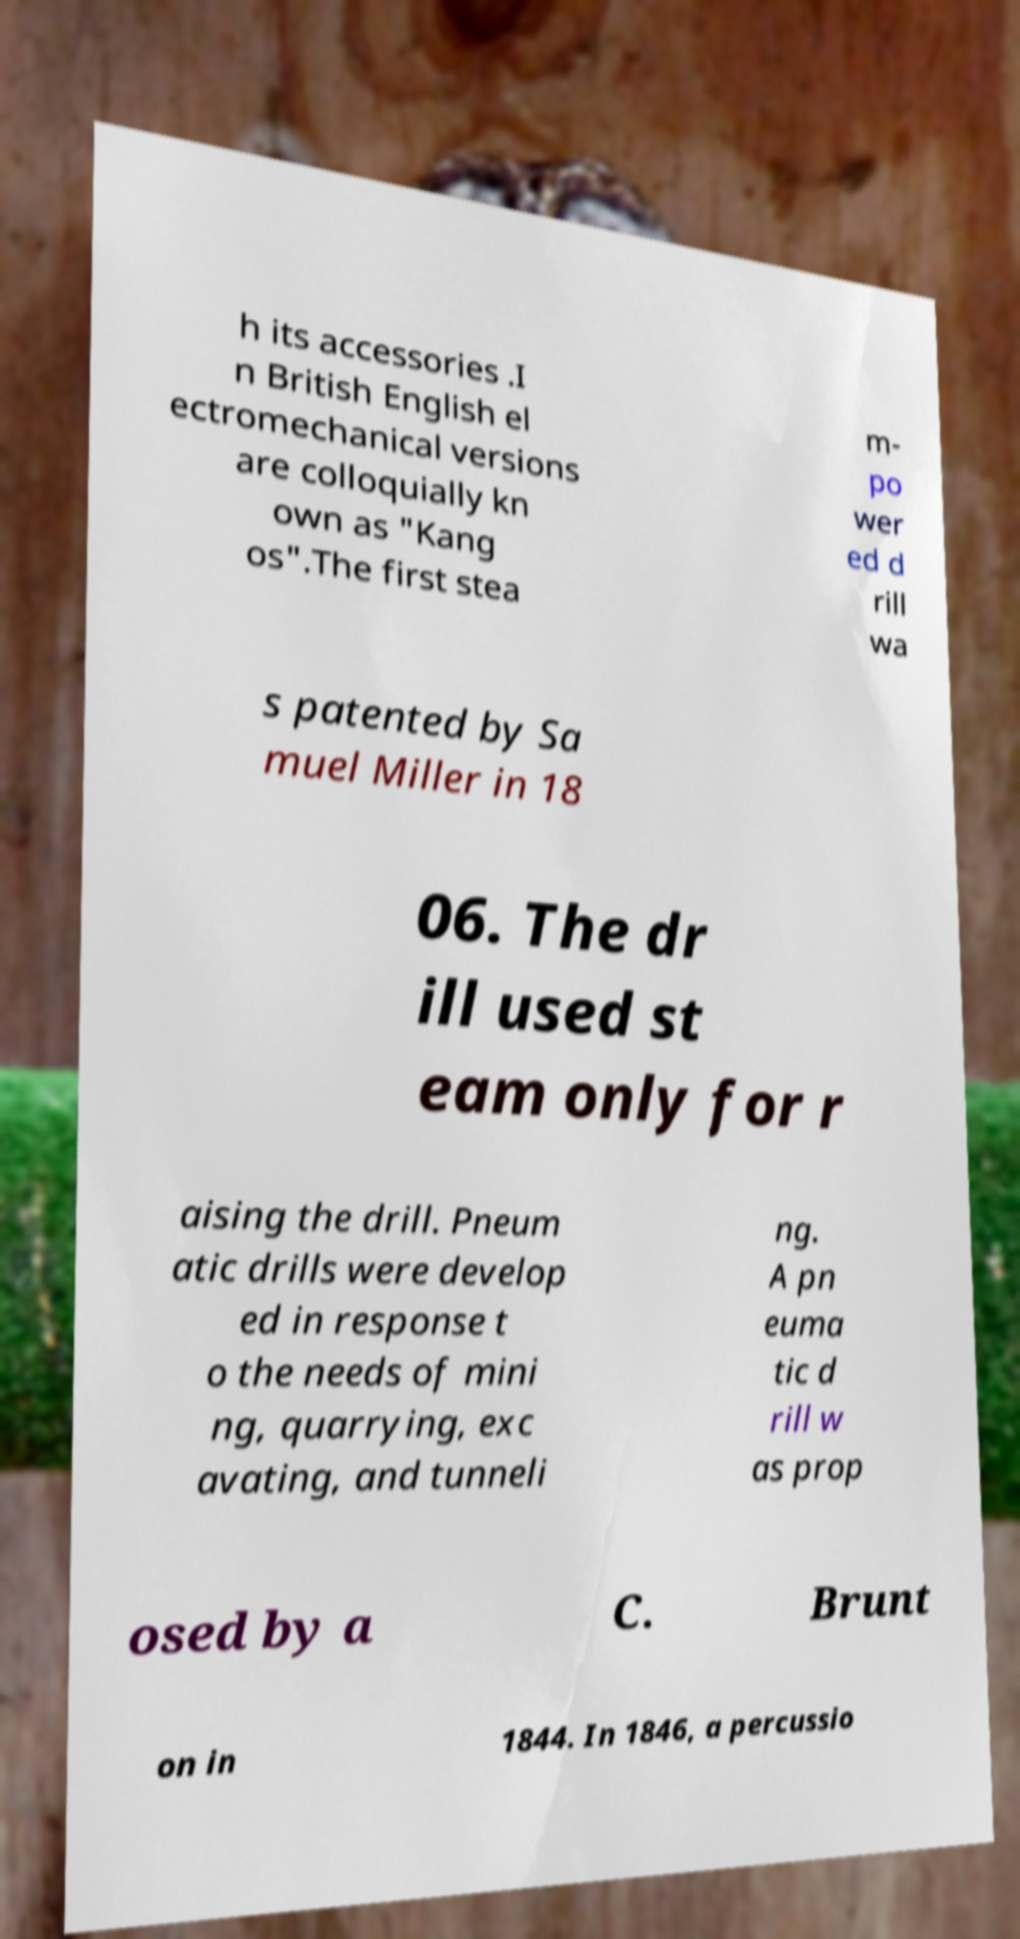There's text embedded in this image that I need extracted. Can you transcribe it verbatim? h its accessories .I n British English el ectromechanical versions are colloquially kn own as "Kang os".The first stea m- po wer ed d rill wa s patented by Sa muel Miller in 18 06. The dr ill used st eam only for r aising the drill. Pneum atic drills were develop ed in response t o the needs of mini ng, quarrying, exc avating, and tunneli ng. A pn euma tic d rill w as prop osed by a C. Brunt on in 1844. In 1846, a percussio 